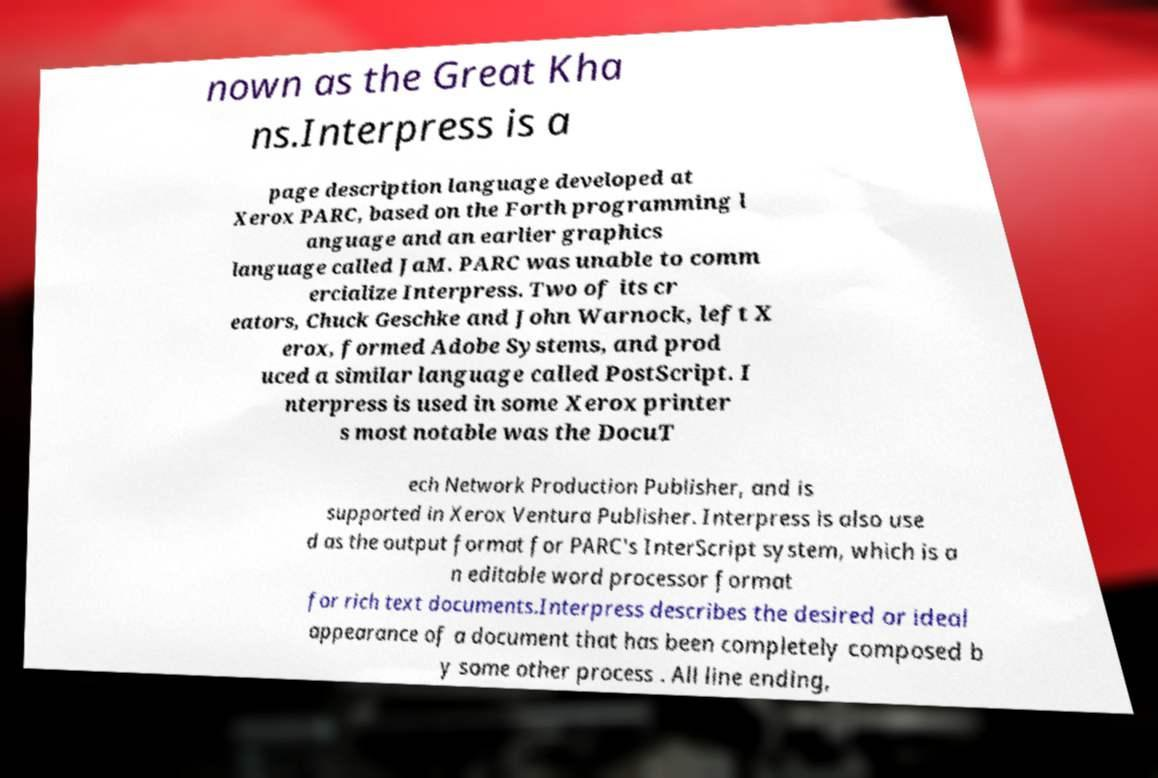I need the written content from this picture converted into text. Can you do that? nown as the Great Kha ns.Interpress is a page description language developed at Xerox PARC, based on the Forth programming l anguage and an earlier graphics language called JaM. PARC was unable to comm ercialize Interpress. Two of its cr eators, Chuck Geschke and John Warnock, left X erox, formed Adobe Systems, and prod uced a similar language called PostScript. I nterpress is used in some Xerox printer s most notable was the DocuT ech Network Production Publisher, and is supported in Xerox Ventura Publisher. Interpress is also use d as the output format for PARC's InterScript system, which is a n editable word processor format for rich text documents.Interpress describes the desired or ideal appearance of a document that has been completely composed b y some other process . All line ending, 